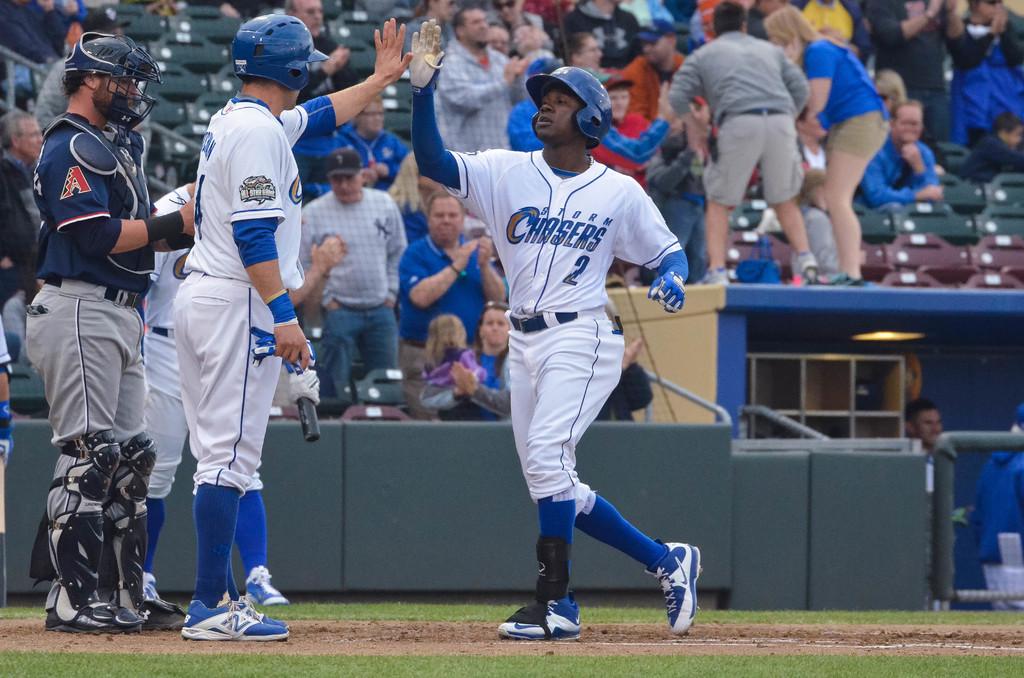Who does the batter play for?
Provide a short and direct response. Storm chasers. What is the number on the guy on the right?
Keep it short and to the point. 2. 